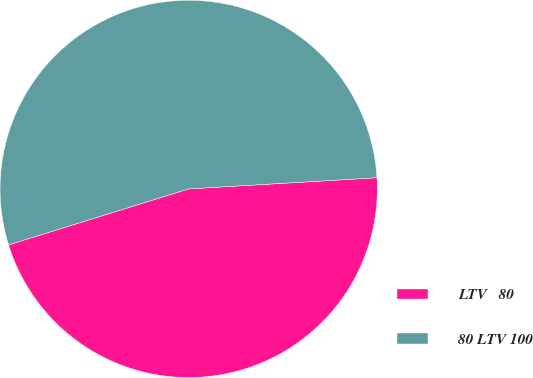<chart> <loc_0><loc_0><loc_500><loc_500><pie_chart><fcel>LTV ≤ 80<fcel>80 LTV 100<nl><fcel>46.15%<fcel>53.85%<nl></chart> 